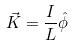Convert formula to latex. <formula><loc_0><loc_0><loc_500><loc_500>\vec { K } = \frac { I } { L } \hat { \phi }</formula> 